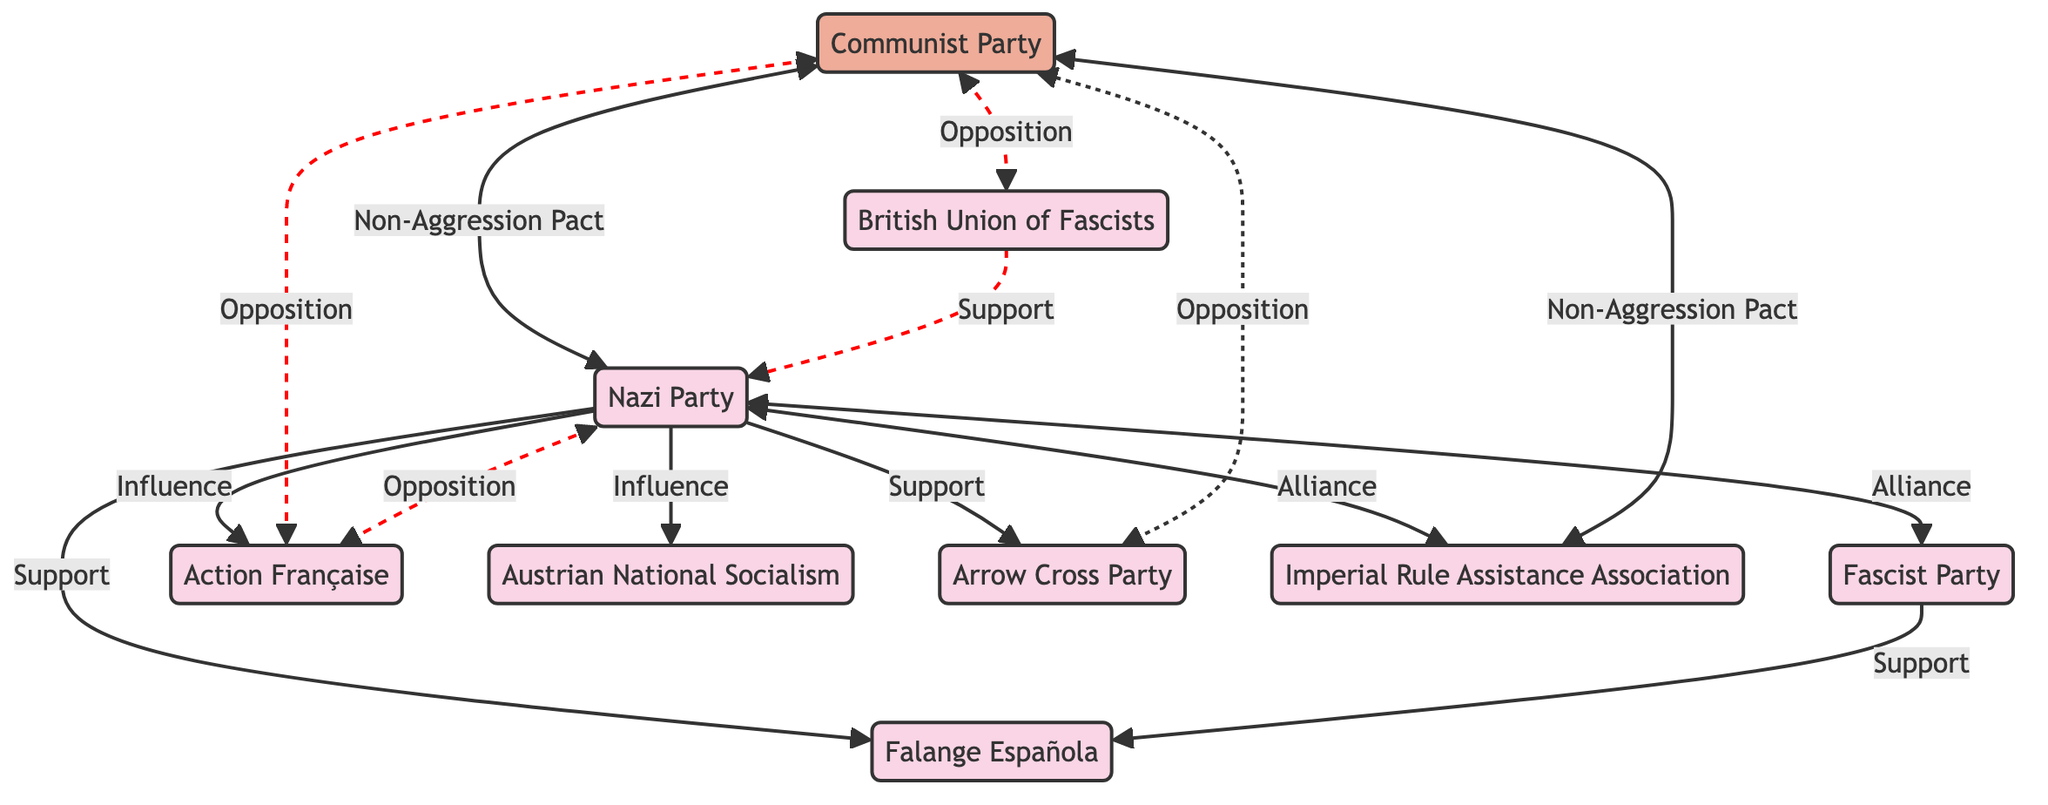What is the relationship between Germany and Italy? The diagram indicates a bi-directional line labeled "Alliance" connecting Germany and Italy. This representation identifies the formal relationship of mutual support and collaboration between these two nationalist entities during the interwar period.
Answer: Alliance How many nation-state nodes are present in the diagram? Counting the individual nodes labeled as nation-states (not including the Communist Party which is categorized as an ideology), we find a total of eight. These nodes are: Nazi Party, Fascist Party, Falange Española, Action Française, Austrian National Socialism, Arrow Cross Party, Imperial Rule Assistance Association, and British Union of Fascists.
Answer: 8 Which nation-state shows support from Germany? The diagram shows that Germany has directed support towards Hungary and Spain, indicated by the arrows labeled "Support" pointing from Germany to these two nation-state nodes. This illustrates Germany's involvement and aid to these nationalistic movements.
Answer: Hungary, Spain What type of relationship does the Soviet Union have with Hungary? The diagram illustrates an "Opposition" relationship between the Soviet Union and Hungary, denoted by a dashed line pointing towards Hungary that conveys a stance of resistance or disapproval.
Answer: Opposition Which nation-state has a non-aggression pact with the Soviet Union? The Soviet Union has established non-aggression pacts with both Germany and Japan, as depicted by dashed lines labeled "Non-Aggression Pact," showing an agreement to avoid military conflict between these nations.
Answer: Germany, Japan What is the connection between France and Germany? The diagram displays a relationship labeled "Opposition" connecting France and Germany. This implies historical tensions and conflicts that characterized their interactions, especially noted during the rise of nationalist sentiments in the interwar period.
Answer: Opposition Which is the only ideology node present in the diagram? The only node categorized under ideology in the diagram is the Communist Party, representing the Soviet Union's ideological stance that contrasted with the various nationalist entities depicted. This highlights its distinctive ideological role amidst the various nation-state nodes.
Answer: Communist Party How many edges are labeled as support in the diagram? By examining the connections originating from Germany, as well as Italy to Spain, the diagram identifies a total of three edges labeled as "Support," illustrating the collaborative framework among the nationalistic groups during this period.
Answer: 3 Does the British Union of Fascists support the Soviet Union? The diagram shows the British Union of Fascists connected to the Soviet Union with a dashed line labeled "Opposition," indicating that rather than supporting the Soviet Union, the British Union has an oppositional stance toward it, reflecting the ideological conflicts of the time.
Answer: No 